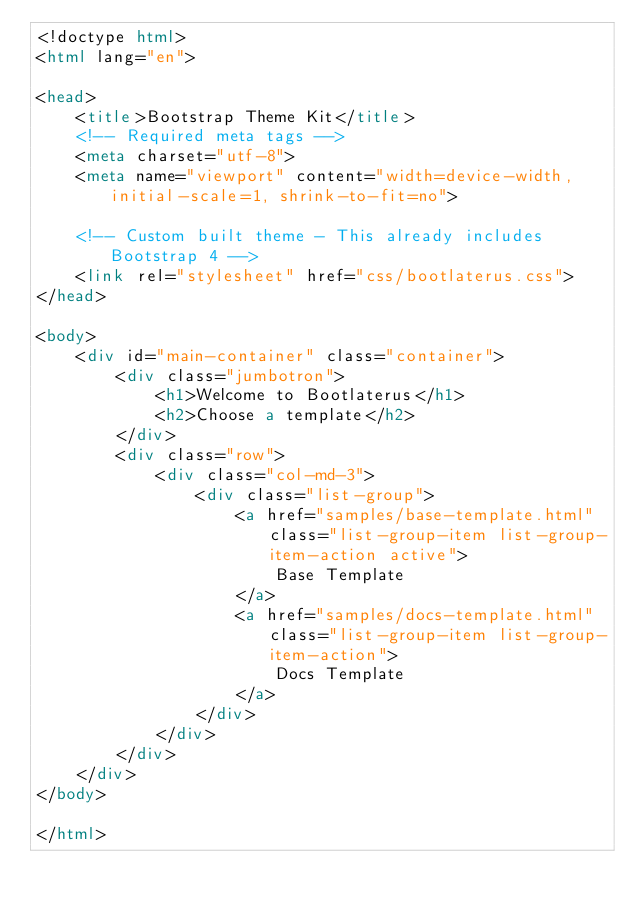Convert code to text. <code><loc_0><loc_0><loc_500><loc_500><_HTML_><!doctype html>
<html lang="en">

<head>
    <title>Bootstrap Theme Kit</title>
    <!-- Required meta tags -->
    <meta charset="utf-8">
    <meta name="viewport" content="width=device-width, initial-scale=1, shrink-to-fit=no">

    <!-- Custom built theme - This already includes Bootstrap 4 -->
    <link rel="stylesheet" href="css/bootlaterus.css">
</head>

<body>
    <div id="main-container" class="container">
        <div class="jumbotron">
            <h1>Welcome to Bootlaterus</h1>
            <h2>Choose a template</h2>
        </div>
        <div class="row">
            <div class="col-md-3">
                <div class="list-group">
                    <a href="samples/base-template.html" class="list-group-item list-group-item-action active">
                        Base Template
                    </a>
                    <a href="samples/docs-template.html" class="list-group-item list-group-item-action">
                        Docs Template
                    </a>
                </div>
            </div>
        </div>
    </div>
</body>

</html></code> 